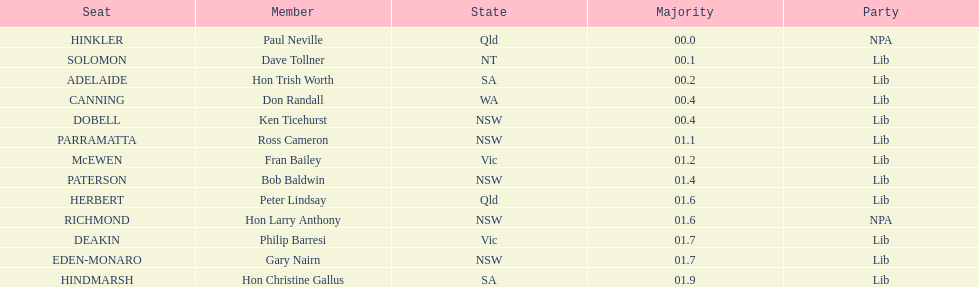Who is listed before don randall? Hon Trish Worth. 